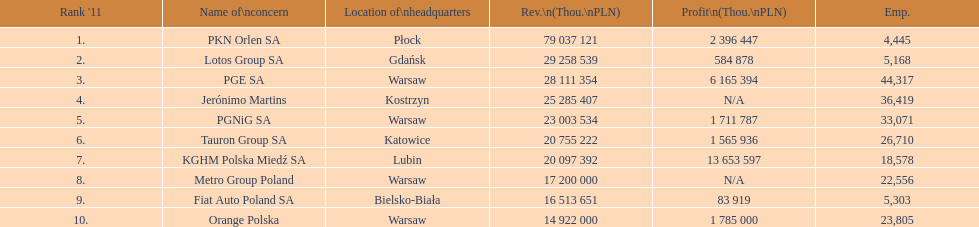Which company had the least revenue? Orange Polska. 